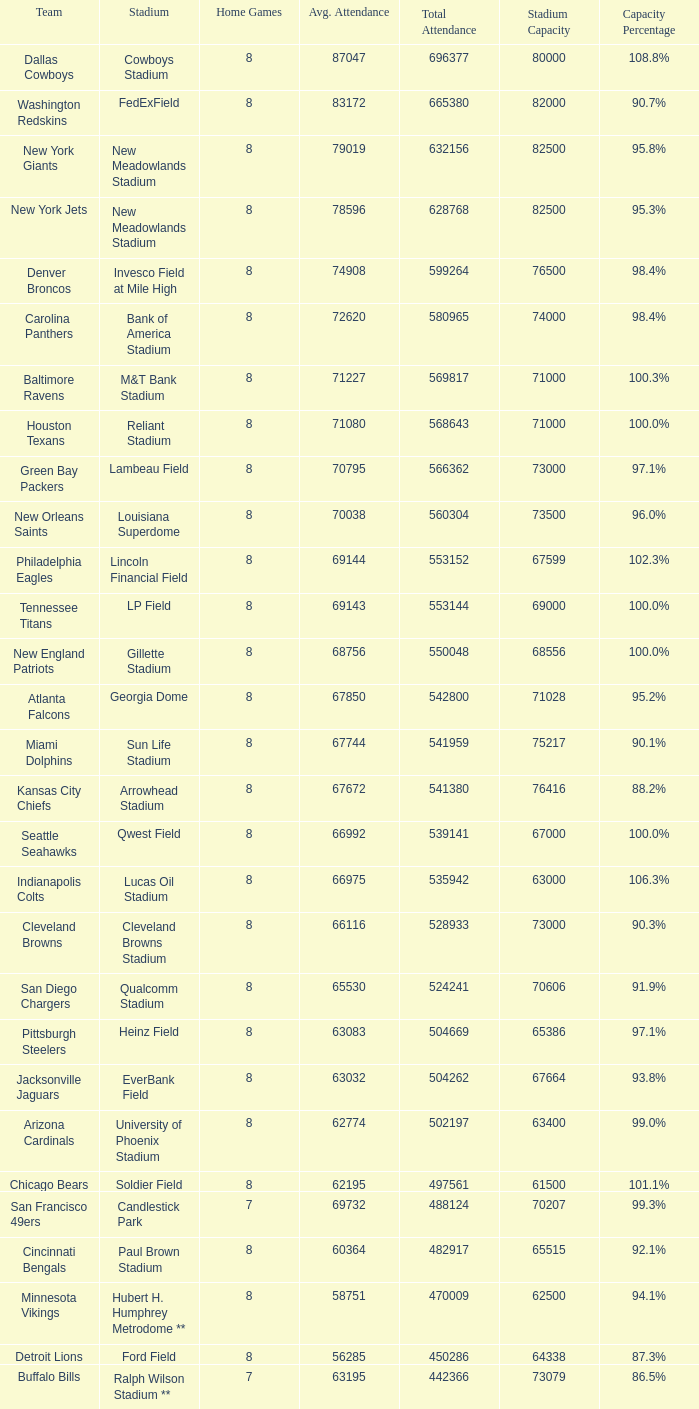How many teams had a 99.3% capacity rating? 1.0. 